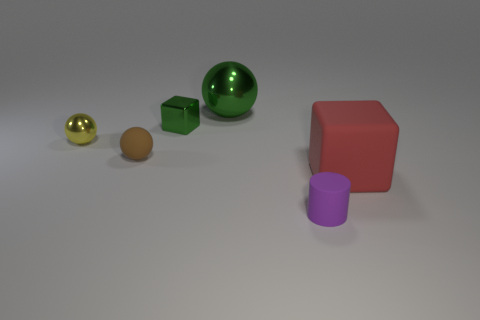Add 2 blocks. How many objects exist? 8 Subtract all blocks. How many objects are left? 4 Subtract 1 green balls. How many objects are left? 5 Subtract all small brown objects. Subtract all metallic cubes. How many objects are left? 4 Add 4 tiny green blocks. How many tiny green blocks are left? 5 Add 2 small cylinders. How many small cylinders exist? 3 